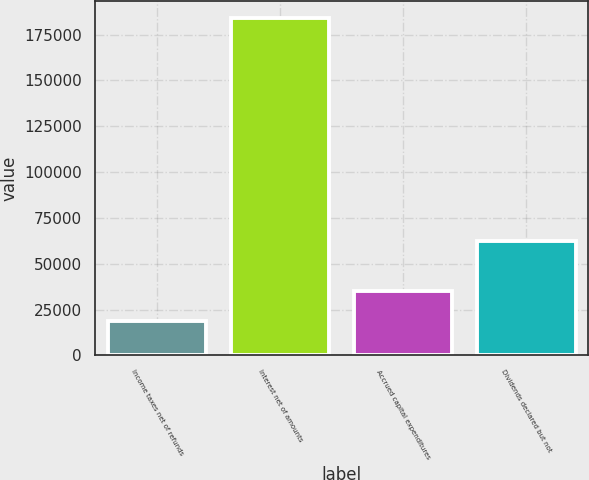Convert chart to OTSL. <chart><loc_0><loc_0><loc_500><loc_500><bar_chart><fcel>Income taxes net of refunds<fcel>Interest net of amounts<fcel>Accrued capital expenditures<fcel>Dividends declared but not<nl><fcel>18537<fcel>184010<fcel>35084.3<fcel>62528<nl></chart> 